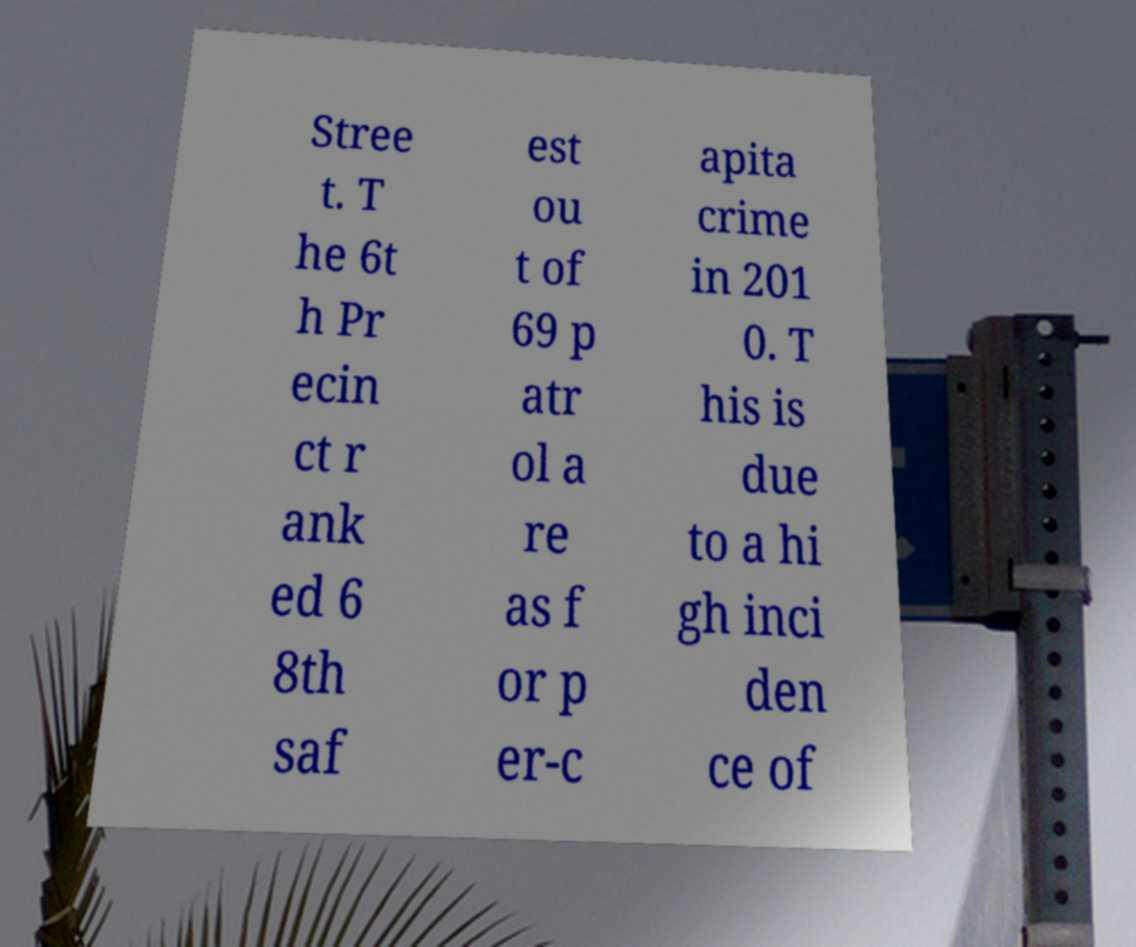Can you accurately transcribe the text from the provided image for me? Stree t. T he 6t h Pr ecin ct r ank ed 6 8th saf est ou t of 69 p atr ol a re as f or p er-c apita crime in 201 0. T his is due to a hi gh inci den ce of 